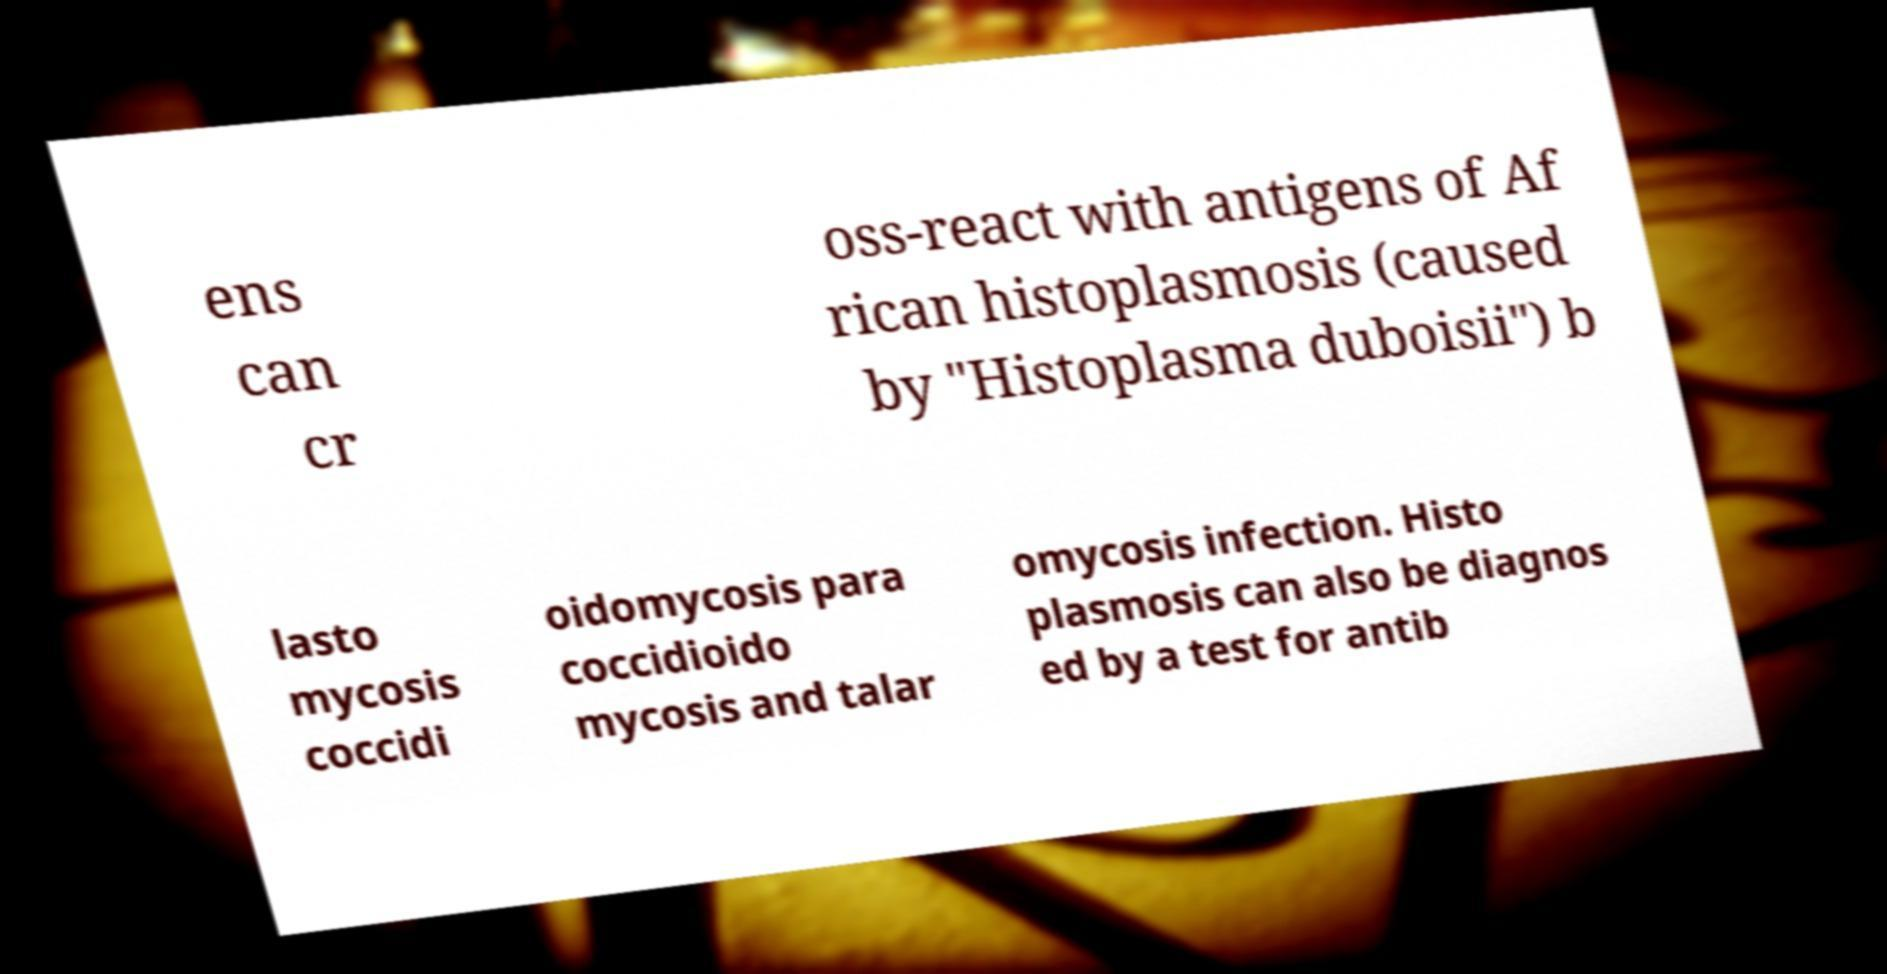There's text embedded in this image that I need extracted. Can you transcribe it verbatim? ens can cr oss-react with antigens of Af rican histoplasmosis (caused by "Histoplasma duboisii") b lasto mycosis coccidi oidomycosis para coccidioido mycosis and talar omycosis infection. Histo plasmosis can also be diagnos ed by a test for antib 